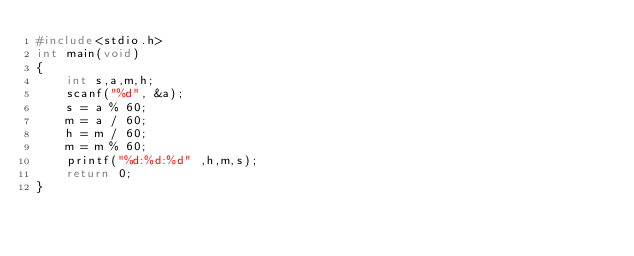<code> <loc_0><loc_0><loc_500><loc_500><_C_>#include<stdio.h>
int main(void)
{
	int s,a,m,h;
	scanf("%d", &a);
	s = a % 60;
	m = a / 60;
	h = m / 60;
	m = m % 60;
	printf("%d:%d:%d" ,h,m,s);
	return 0;
}</code> 